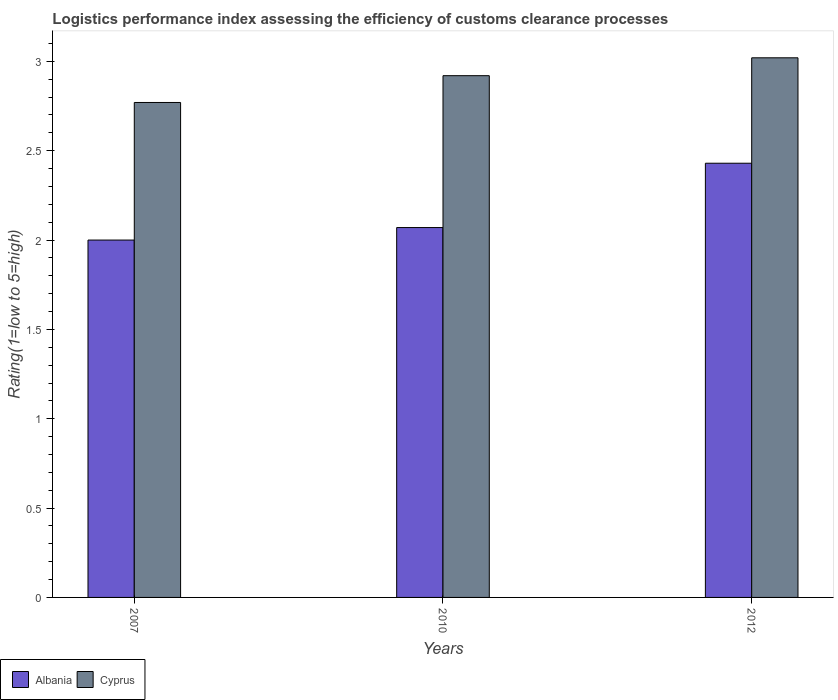Are the number of bars per tick equal to the number of legend labels?
Provide a short and direct response. Yes. How many bars are there on the 1st tick from the left?
Provide a short and direct response. 2. How many bars are there on the 2nd tick from the right?
Your answer should be compact. 2. What is the label of the 2nd group of bars from the left?
Give a very brief answer. 2010. What is the Logistic performance index in Cyprus in 2010?
Make the answer very short. 2.92. Across all years, what is the maximum Logistic performance index in Albania?
Ensure brevity in your answer.  2.43. Across all years, what is the minimum Logistic performance index in Cyprus?
Provide a succinct answer. 2.77. What is the total Logistic performance index in Albania in the graph?
Offer a very short reply. 6.5. What is the difference between the Logistic performance index in Albania in 2007 and that in 2012?
Provide a short and direct response. -0.43. What is the difference between the Logistic performance index in Cyprus in 2007 and the Logistic performance index in Albania in 2012?
Provide a short and direct response. 0.34. What is the average Logistic performance index in Cyprus per year?
Keep it short and to the point. 2.9. In the year 2012, what is the difference between the Logistic performance index in Cyprus and Logistic performance index in Albania?
Provide a short and direct response. 0.59. What is the ratio of the Logistic performance index in Albania in 2007 to that in 2012?
Provide a short and direct response. 0.82. Is the Logistic performance index in Cyprus in 2007 less than that in 2012?
Provide a succinct answer. Yes. What is the difference between the highest and the second highest Logistic performance index in Cyprus?
Your answer should be compact. 0.1. What is the difference between the highest and the lowest Logistic performance index in Albania?
Provide a succinct answer. 0.43. In how many years, is the Logistic performance index in Cyprus greater than the average Logistic performance index in Cyprus taken over all years?
Your answer should be compact. 2. Is the sum of the Logistic performance index in Albania in 2007 and 2010 greater than the maximum Logistic performance index in Cyprus across all years?
Offer a terse response. Yes. What does the 2nd bar from the left in 2007 represents?
Offer a terse response. Cyprus. What does the 2nd bar from the right in 2007 represents?
Offer a terse response. Albania. How many bars are there?
Provide a succinct answer. 6. Are all the bars in the graph horizontal?
Give a very brief answer. No. Does the graph contain grids?
Ensure brevity in your answer.  No. How are the legend labels stacked?
Offer a terse response. Horizontal. What is the title of the graph?
Ensure brevity in your answer.  Logistics performance index assessing the efficiency of customs clearance processes. Does "Canada" appear as one of the legend labels in the graph?
Ensure brevity in your answer.  No. What is the label or title of the Y-axis?
Provide a short and direct response. Rating(1=low to 5=high). What is the Rating(1=low to 5=high) in Albania in 2007?
Make the answer very short. 2. What is the Rating(1=low to 5=high) in Cyprus in 2007?
Offer a terse response. 2.77. What is the Rating(1=low to 5=high) of Albania in 2010?
Your response must be concise. 2.07. What is the Rating(1=low to 5=high) of Cyprus in 2010?
Offer a terse response. 2.92. What is the Rating(1=low to 5=high) of Albania in 2012?
Your response must be concise. 2.43. What is the Rating(1=low to 5=high) of Cyprus in 2012?
Offer a very short reply. 3.02. Across all years, what is the maximum Rating(1=low to 5=high) of Albania?
Offer a very short reply. 2.43. Across all years, what is the maximum Rating(1=low to 5=high) of Cyprus?
Your response must be concise. 3.02. Across all years, what is the minimum Rating(1=low to 5=high) of Cyprus?
Ensure brevity in your answer.  2.77. What is the total Rating(1=low to 5=high) in Cyprus in the graph?
Your response must be concise. 8.71. What is the difference between the Rating(1=low to 5=high) of Albania in 2007 and that in 2010?
Provide a succinct answer. -0.07. What is the difference between the Rating(1=low to 5=high) of Cyprus in 2007 and that in 2010?
Offer a very short reply. -0.15. What is the difference between the Rating(1=low to 5=high) in Albania in 2007 and that in 2012?
Offer a very short reply. -0.43. What is the difference between the Rating(1=low to 5=high) in Albania in 2010 and that in 2012?
Make the answer very short. -0.36. What is the difference between the Rating(1=low to 5=high) of Albania in 2007 and the Rating(1=low to 5=high) of Cyprus in 2010?
Your answer should be very brief. -0.92. What is the difference between the Rating(1=low to 5=high) in Albania in 2007 and the Rating(1=low to 5=high) in Cyprus in 2012?
Your response must be concise. -1.02. What is the difference between the Rating(1=low to 5=high) of Albania in 2010 and the Rating(1=low to 5=high) of Cyprus in 2012?
Keep it short and to the point. -0.95. What is the average Rating(1=low to 5=high) of Albania per year?
Your response must be concise. 2.17. What is the average Rating(1=low to 5=high) of Cyprus per year?
Provide a succinct answer. 2.9. In the year 2007, what is the difference between the Rating(1=low to 5=high) of Albania and Rating(1=low to 5=high) of Cyprus?
Provide a short and direct response. -0.77. In the year 2010, what is the difference between the Rating(1=low to 5=high) of Albania and Rating(1=low to 5=high) of Cyprus?
Your answer should be compact. -0.85. In the year 2012, what is the difference between the Rating(1=low to 5=high) of Albania and Rating(1=low to 5=high) of Cyprus?
Your response must be concise. -0.59. What is the ratio of the Rating(1=low to 5=high) of Albania in 2007 to that in 2010?
Make the answer very short. 0.97. What is the ratio of the Rating(1=low to 5=high) of Cyprus in 2007 to that in 2010?
Provide a succinct answer. 0.95. What is the ratio of the Rating(1=low to 5=high) in Albania in 2007 to that in 2012?
Ensure brevity in your answer.  0.82. What is the ratio of the Rating(1=low to 5=high) of Cyprus in 2007 to that in 2012?
Your answer should be compact. 0.92. What is the ratio of the Rating(1=low to 5=high) in Albania in 2010 to that in 2012?
Keep it short and to the point. 0.85. What is the ratio of the Rating(1=low to 5=high) of Cyprus in 2010 to that in 2012?
Keep it short and to the point. 0.97. What is the difference between the highest and the second highest Rating(1=low to 5=high) in Albania?
Offer a very short reply. 0.36. What is the difference between the highest and the lowest Rating(1=low to 5=high) of Albania?
Your answer should be compact. 0.43. 